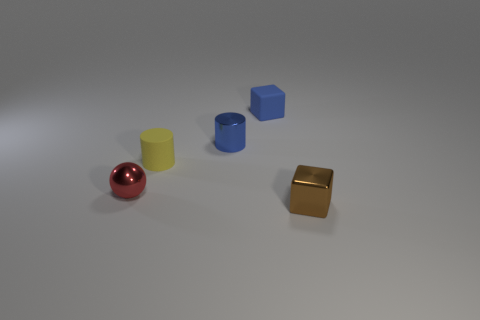Is there a tiny block of the same color as the metal cylinder?
Your response must be concise. Yes. The blue matte object has what shape?
Keep it short and to the point. Cube. What is the color of the tiny shiny thing that is to the right of the cube behind the brown metallic thing?
Provide a succinct answer. Brown. What size is the rubber object behind the small blue cylinder?
Offer a very short reply. Small. Are there any tiny yellow cylinders made of the same material as the small brown block?
Your response must be concise. No. How many other tiny metallic objects are the same shape as the small yellow object?
Make the answer very short. 1. There is a matte object that is behind the tiny matte object left of the block that is behind the small yellow matte thing; what shape is it?
Offer a terse response. Cube. What is the small thing that is behind the small ball and to the left of the blue metal thing made of?
Offer a terse response. Rubber. Is the size of the block that is in front of the rubber cylinder the same as the tiny blue metal cylinder?
Your response must be concise. Yes. Is the number of brown objects right of the tiny blue block greater than the number of metal cylinders in front of the shiny cylinder?
Keep it short and to the point. Yes. 